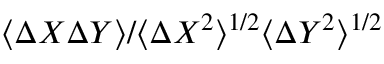<formula> <loc_0><loc_0><loc_500><loc_500>\langle { \mathit \Delta } X { \mathit \Delta } Y \rangle / \langle { \mathit \Delta } X ^ { 2 } \rangle ^ { 1 / 2 } \langle { \mathit \Delta } Y ^ { 2 } \rangle ^ { 1 / 2 }</formula> 